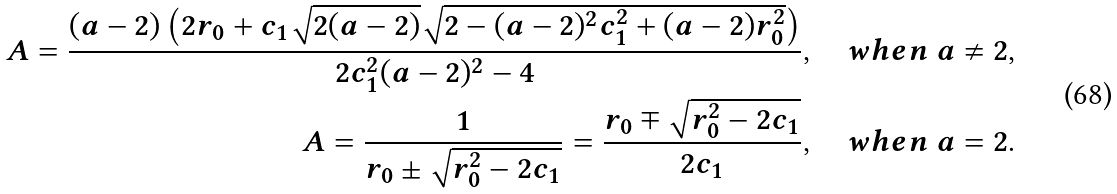Convert formula to latex. <formula><loc_0><loc_0><loc_500><loc_500>A = \frac { ( a - 2 ) \left ( 2 r _ { 0 } + c _ { 1 } \sqrt { 2 ( a - 2 ) } \sqrt { 2 - ( a - 2 ) ^ { 2 } c _ { 1 } ^ { 2 } + ( a - 2 ) r _ { 0 } ^ { 2 } } \right ) } { 2 c _ { 1 } ^ { 2 } ( a - 2 ) ^ { 2 } - 4 } , \quad w h e n \ a \neq 2 , \\ A = \frac { 1 } { r _ { 0 } \pm \sqrt { r _ { 0 } ^ { 2 } - 2 c _ { 1 } } } = \frac { r _ { 0 } \mp \sqrt { r _ { 0 } ^ { 2 } - 2 c _ { 1 } } } { 2 c _ { 1 } } , \quad w h e n \ a = 2 .</formula> 